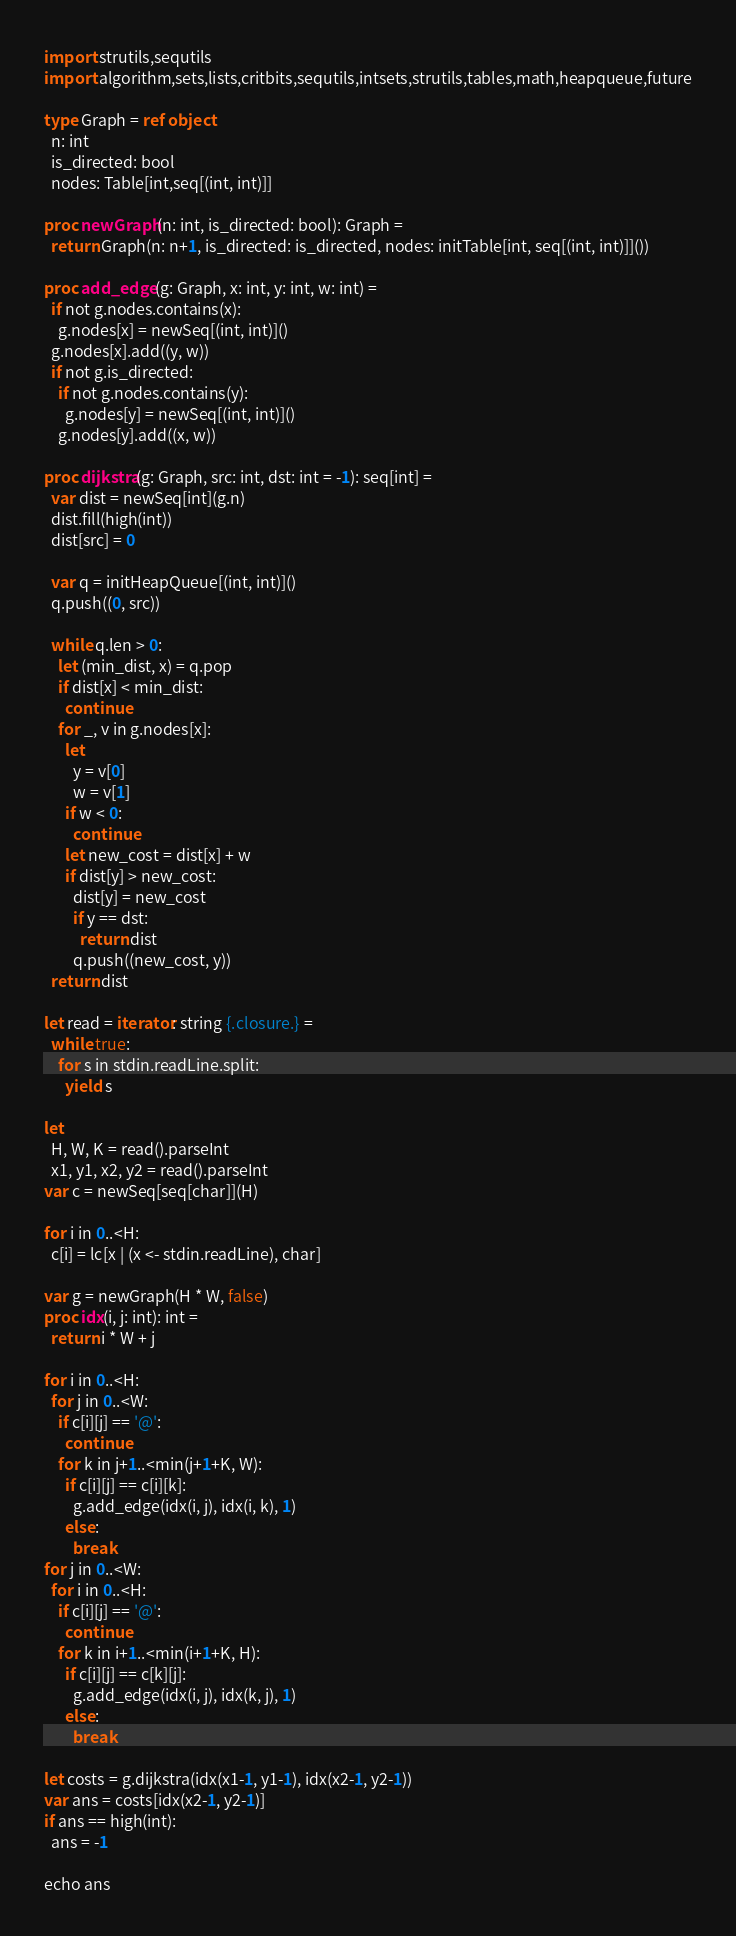Convert code to text. <code><loc_0><loc_0><loc_500><loc_500><_Nim_>import strutils,sequtils
import algorithm,sets,lists,critbits,sequtils,intsets,strutils,tables,math,heapqueue,future

type Graph = ref object
  n: int
  is_directed: bool
  nodes: Table[int,seq[(int, int)]]

proc newGraph(n: int, is_directed: bool): Graph =
  return Graph(n: n+1, is_directed: is_directed, nodes: initTable[int, seq[(int, int)]]())

proc add_edge(g: Graph, x: int, y: int, w: int) =
  if not g.nodes.contains(x):
    g.nodes[x] = newSeq[(int, int)]()
  g.nodes[x].add((y, w))
  if not g.is_directed:
    if not g.nodes.contains(y):
      g.nodes[y] = newSeq[(int, int)]()
    g.nodes[y].add((x, w))

proc dijkstra(g: Graph, src: int, dst: int = -1): seq[int] =
  var dist = newSeq[int](g.n)
  dist.fill(high(int))
  dist[src] = 0

  var q = initHeapQueue[(int, int)]()
  q.push((0, src))

  while q.len > 0:
    let (min_dist, x) = q.pop
    if dist[x] < min_dist:
      continue
    for _, v in g.nodes[x]:
      let
        y = v[0]
        w = v[1]
      if w < 0:
        continue
      let new_cost = dist[x] + w
      if dist[y] > new_cost:
        dist[y] = new_cost
        if y == dst:
          return dist
        q.push((new_cost, y))
  return dist

let read = iterator: string {.closure.} =
  while true:
    for s in stdin.readLine.split:
      yield s

let 
  H, W, K = read().parseInt
  x1, y1, x2, y2 = read().parseInt
var c = newSeq[seq[char]](H)

for i in 0..<H:
  c[i] = lc[x | (x <- stdin.readLine), char]

var g = newGraph(H * W, false)
proc idx(i, j: int): int =
  return i * W + j

for i in 0..<H:
  for j in 0..<W:
    if c[i][j] == '@':
      continue
    for k in j+1..<min(j+1+K, W):
      if c[i][j] == c[i][k]:
        g.add_edge(idx(i, j), idx(i, k), 1)
      else:
        break
for j in 0..<W:
  for i in 0..<H:
    if c[i][j] == '@':
      continue
    for k in i+1..<min(i+1+K, H):
      if c[i][j] == c[k][j]:
        g.add_edge(idx(i, j), idx(k, j), 1)
      else:
        break

let costs = g.dijkstra(idx(x1-1, y1-1), idx(x2-1, y2-1))
var ans = costs[idx(x2-1, y2-1)]
if ans == high(int):
  ans = -1

echo ans
</code> 